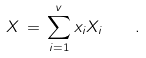Convert formula to latex. <formula><loc_0><loc_0><loc_500><loc_500>X \, = \, \sum _ { i = 1 } ^ { v } x _ { i } X _ { i } \quad .</formula> 